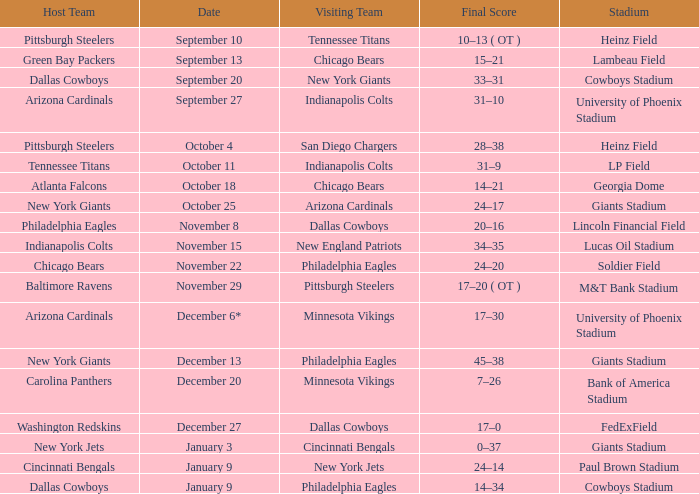I want to know the stadium for tennessee titans visiting Heinz Field. 